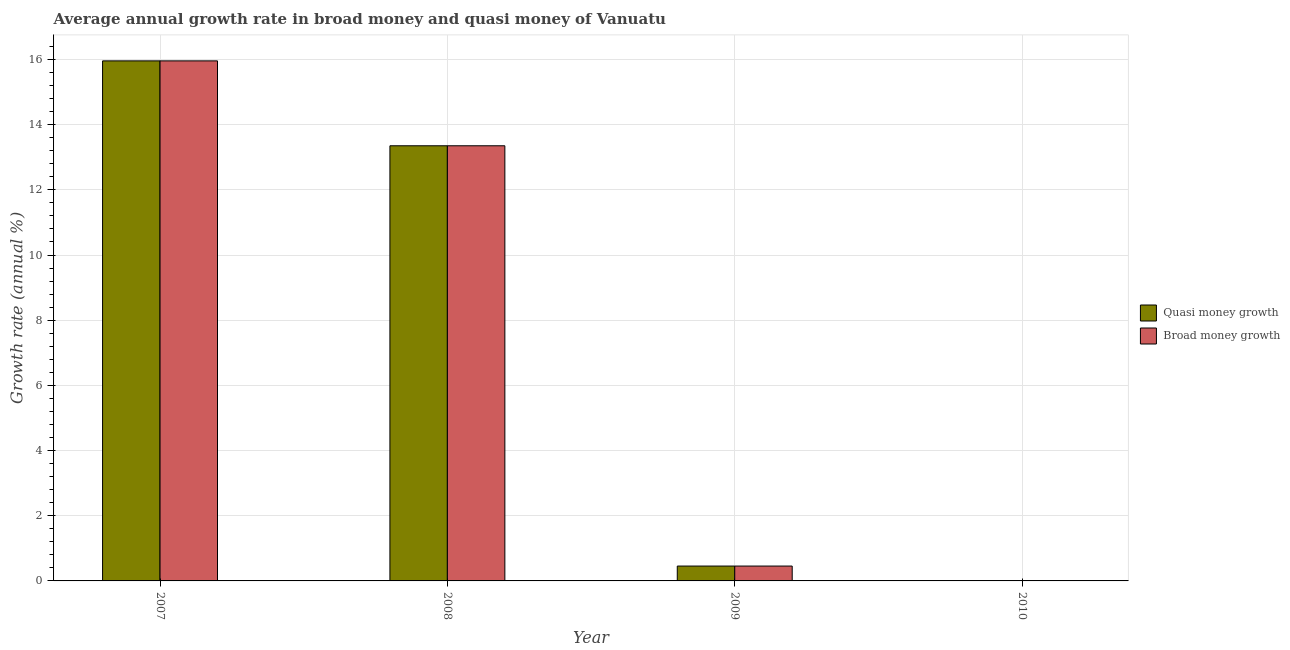How many different coloured bars are there?
Your answer should be very brief. 2. Are the number of bars per tick equal to the number of legend labels?
Provide a short and direct response. No. How many bars are there on the 3rd tick from the left?
Give a very brief answer. 2. How many bars are there on the 3rd tick from the right?
Your answer should be compact. 2. What is the annual growth rate in broad money in 2009?
Offer a very short reply. 0.46. Across all years, what is the maximum annual growth rate in broad money?
Offer a terse response. 15.96. Across all years, what is the minimum annual growth rate in quasi money?
Provide a short and direct response. 0. What is the total annual growth rate in quasi money in the graph?
Your answer should be compact. 29.76. What is the difference between the annual growth rate in quasi money in 2007 and that in 2009?
Offer a very short reply. 15.5. What is the difference between the annual growth rate in quasi money in 2008 and the annual growth rate in broad money in 2007?
Offer a very short reply. -2.61. What is the average annual growth rate in quasi money per year?
Keep it short and to the point. 7.44. In the year 2007, what is the difference between the annual growth rate in broad money and annual growth rate in quasi money?
Ensure brevity in your answer.  0. What is the ratio of the annual growth rate in broad money in 2008 to that in 2009?
Make the answer very short. 29.27. Is the annual growth rate in quasi money in 2007 less than that in 2008?
Your answer should be compact. No. Is the difference between the annual growth rate in broad money in 2007 and 2008 greater than the difference between the annual growth rate in quasi money in 2007 and 2008?
Your answer should be compact. No. What is the difference between the highest and the second highest annual growth rate in broad money?
Ensure brevity in your answer.  2.61. What is the difference between the highest and the lowest annual growth rate in broad money?
Offer a terse response. 15.96. Is the sum of the annual growth rate in broad money in 2007 and 2009 greater than the maximum annual growth rate in quasi money across all years?
Give a very brief answer. Yes. Are all the bars in the graph horizontal?
Offer a very short reply. No. How many years are there in the graph?
Your answer should be compact. 4. Does the graph contain grids?
Your response must be concise. Yes. Where does the legend appear in the graph?
Give a very brief answer. Center right. How many legend labels are there?
Offer a terse response. 2. What is the title of the graph?
Ensure brevity in your answer.  Average annual growth rate in broad money and quasi money of Vanuatu. Does "Under-five" appear as one of the legend labels in the graph?
Your response must be concise. No. What is the label or title of the X-axis?
Provide a succinct answer. Year. What is the label or title of the Y-axis?
Your answer should be very brief. Growth rate (annual %). What is the Growth rate (annual %) of Quasi money growth in 2007?
Give a very brief answer. 15.96. What is the Growth rate (annual %) of Broad money growth in 2007?
Keep it short and to the point. 15.96. What is the Growth rate (annual %) in Quasi money growth in 2008?
Give a very brief answer. 13.35. What is the Growth rate (annual %) in Broad money growth in 2008?
Your answer should be compact. 13.35. What is the Growth rate (annual %) in Quasi money growth in 2009?
Provide a short and direct response. 0.46. What is the Growth rate (annual %) in Broad money growth in 2009?
Provide a short and direct response. 0.46. What is the Growth rate (annual %) of Quasi money growth in 2010?
Offer a terse response. 0. Across all years, what is the maximum Growth rate (annual %) of Quasi money growth?
Your answer should be compact. 15.96. Across all years, what is the maximum Growth rate (annual %) in Broad money growth?
Keep it short and to the point. 15.96. Across all years, what is the minimum Growth rate (annual %) of Quasi money growth?
Provide a short and direct response. 0. Across all years, what is the minimum Growth rate (annual %) in Broad money growth?
Give a very brief answer. 0. What is the total Growth rate (annual %) of Quasi money growth in the graph?
Provide a short and direct response. 29.76. What is the total Growth rate (annual %) in Broad money growth in the graph?
Provide a succinct answer. 29.76. What is the difference between the Growth rate (annual %) in Quasi money growth in 2007 and that in 2008?
Make the answer very short. 2.61. What is the difference between the Growth rate (annual %) of Broad money growth in 2007 and that in 2008?
Offer a terse response. 2.61. What is the difference between the Growth rate (annual %) of Quasi money growth in 2007 and that in 2009?
Give a very brief answer. 15.5. What is the difference between the Growth rate (annual %) in Broad money growth in 2007 and that in 2009?
Give a very brief answer. 15.5. What is the difference between the Growth rate (annual %) of Quasi money growth in 2008 and that in 2009?
Your answer should be compact. 12.9. What is the difference between the Growth rate (annual %) in Broad money growth in 2008 and that in 2009?
Your response must be concise. 12.9. What is the difference between the Growth rate (annual %) in Quasi money growth in 2007 and the Growth rate (annual %) in Broad money growth in 2008?
Ensure brevity in your answer.  2.61. What is the difference between the Growth rate (annual %) of Quasi money growth in 2007 and the Growth rate (annual %) of Broad money growth in 2009?
Your answer should be very brief. 15.5. What is the difference between the Growth rate (annual %) in Quasi money growth in 2008 and the Growth rate (annual %) in Broad money growth in 2009?
Make the answer very short. 12.9. What is the average Growth rate (annual %) of Quasi money growth per year?
Your answer should be very brief. 7.44. What is the average Growth rate (annual %) in Broad money growth per year?
Give a very brief answer. 7.44. In the year 2007, what is the difference between the Growth rate (annual %) of Quasi money growth and Growth rate (annual %) of Broad money growth?
Offer a very short reply. 0. In the year 2008, what is the difference between the Growth rate (annual %) of Quasi money growth and Growth rate (annual %) of Broad money growth?
Offer a terse response. 0. What is the ratio of the Growth rate (annual %) in Quasi money growth in 2007 to that in 2008?
Your answer should be compact. 1.2. What is the ratio of the Growth rate (annual %) of Broad money growth in 2007 to that in 2008?
Offer a terse response. 1.2. What is the ratio of the Growth rate (annual %) in Quasi money growth in 2007 to that in 2009?
Offer a very short reply. 34.99. What is the ratio of the Growth rate (annual %) of Broad money growth in 2007 to that in 2009?
Ensure brevity in your answer.  34.99. What is the ratio of the Growth rate (annual %) in Quasi money growth in 2008 to that in 2009?
Give a very brief answer. 29.27. What is the ratio of the Growth rate (annual %) in Broad money growth in 2008 to that in 2009?
Make the answer very short. 29.27. What is the difference between the highest and the second highest Growth rate (annual %) in Quasi money growth?
Give a very brief answer. 2.61. What is the difference between the highest and the second highest Growth rate (annual %) in Broad money growth?
Give a very brief answer. 2.61. What is the difference between the highest and the lowest Growth rate (annual %) in Quasi money growth?
Your answer should be compact. 15.96. What is the difference between the highest and the lowest Growth rate (annual %) in Broad money growth?
Offer a very short reply. 15.96. 